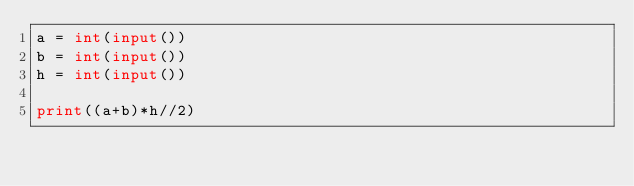<code> <loc_0><loc_0><loc_500><loc_500><_Python_>a = int(input())
b = int(input())
h = int(input())

print((a+b)*h//2)
</code> 